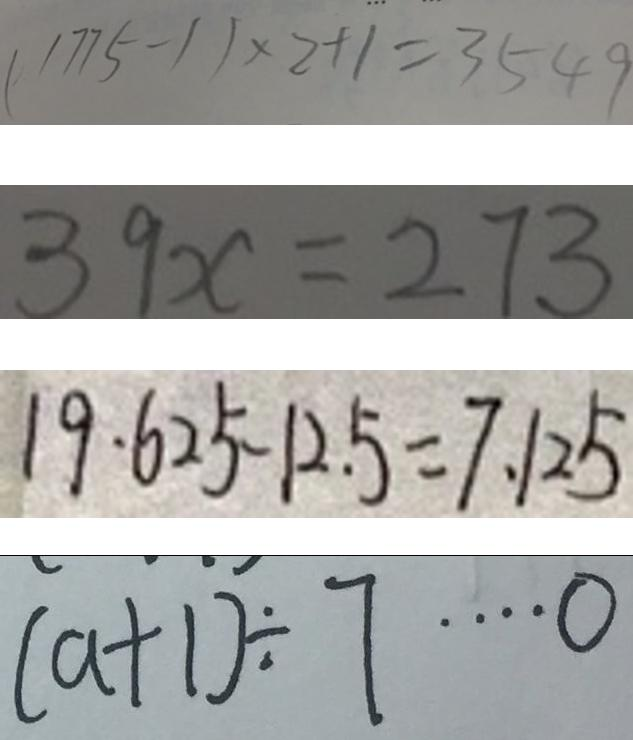<formula> <loc_0><loc_0><loc_500><loc_500>( 1 7 7 5 - 1 ) \times 2 + 1 = 3 5 4 9 
 3 9 x = 2 7 3 
 1 9 \cdot 6 2 5 - 1 2 . 5 = 7 . 1 2 5 
 ( a + 1 ) \div 7 \cdots 0</formula> 